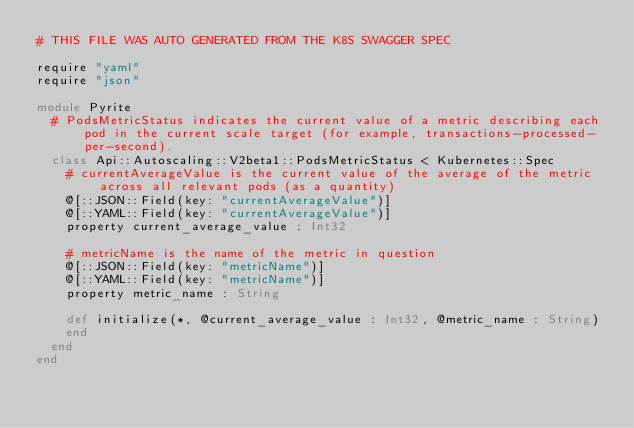Convert code to text. <code><loc_0><loc_0><loc_500><loc_500><_Crystal_># THIS FILE WAS AUTO GENERATED FROM THE K8S SWAGGER SPEC

require "yaml"
require "json"

module Pyrite
  # PodsMetricStatus indicates the current value of a metric describing each pod in the current scale target (for example, transactions-processed-per-second).
  class Api::Autoscaling::V2beta1::PodsMetricStatus < Kubernetes::Spec
    # currentAverageValue is the current value of the average of the metric across all relevant pods (as a quantity)
    @[::JSON::Field(key: "currentAverageValue")]
    @[::YAML::Field(key: "currentAverageValue")]
    property current_average_value : Int32

    # metricName is the name of the metric in question
    @[::JSON::Field(key: "metricName")]
    @[::YAML::Field(key: "metricName")]
    property metric_name : String

    def initialize(*, @current_average_value : Int32, @metric_name : String)
    end
  end
end
</code> 